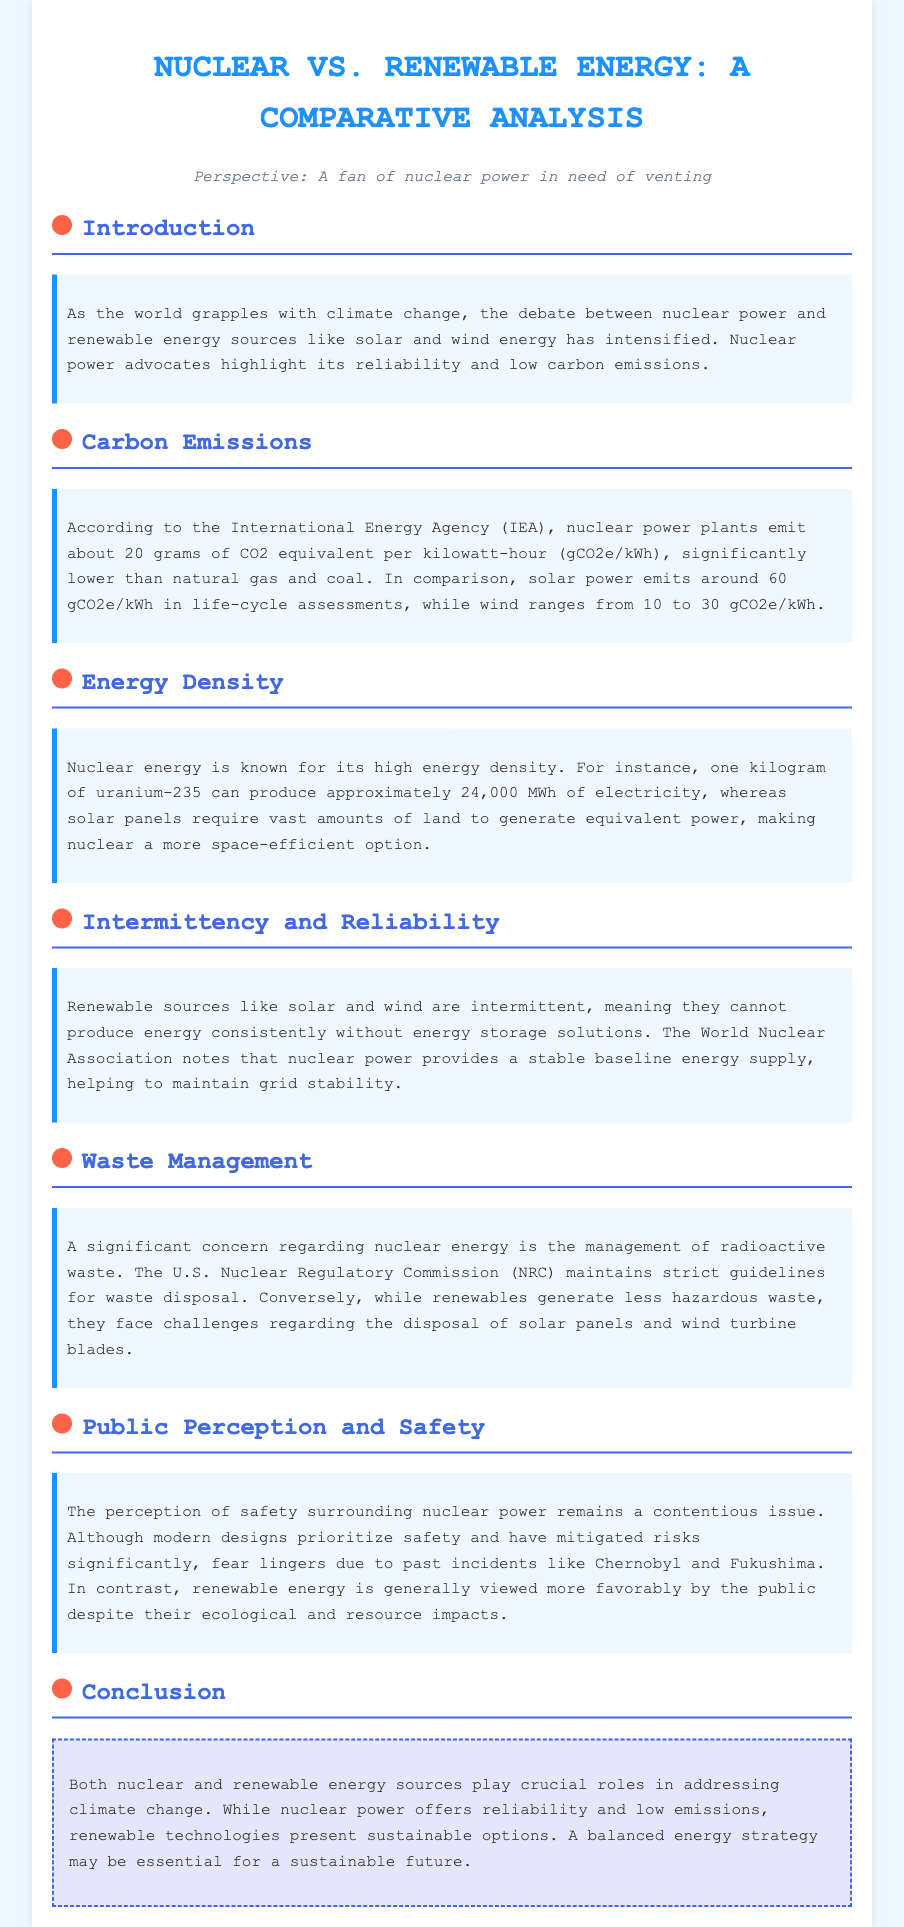What is the CO2 equivalent emission of nuclear power per kilowatt-hour? The document states that nuclear power plants emit about 20 grams of CO2 equivalent per kilowatt-hour.
Answer: 20 grams What is the main advantage of nuclear energy in terms of land use? The document highlights that nuclear energy is known for its high energy density, making it a more space-efficient option compared to solar panels.
Answer: Space-efficient What are the carbon emissions of solar power according to the document? The document says that solar power emits around 60 grams of CO2 equivalent per kilowatt-hour in life-cycle assessments.
Answer: 60 grams Why is nuclear power considered reliable in energy production? The document mentions that nuclear power provides a stable baseline energy supply, helping to maintain grid stability.
Answer: Stable baseline energy supply What major concern is associated with nuclear energy? The document indicates that a significant concern regarding nuclear energy is the management of radioactive waste.
Answer: Radioactive waste Which past nuclear incidents are mentioned as affecting public perception? The document refers to past incidents like Chernobyl and Fukushima as contributing to the fear surrounding nuclear power.
Answer: Chernobyl and Fukushima What do renewable sources like solar and wind face in terms of energy production? The document states that renewable sources like solar and wind are intermittent and cannot produce energy consistently without energy storage solutions.
Answer: Intermittent What is one environmental challenge faced by renewable energy mentioned in the document? The document points out that renewables face challenges regarding the disposal of solar panels and wind turbine blades.
Answer: Disposal challenges What does the conclusion suggest about energy strategy for the future? The conclusion states that a balanced energy strategy may be essential for a sustainable future.
Answer: Balanced energy strategy 